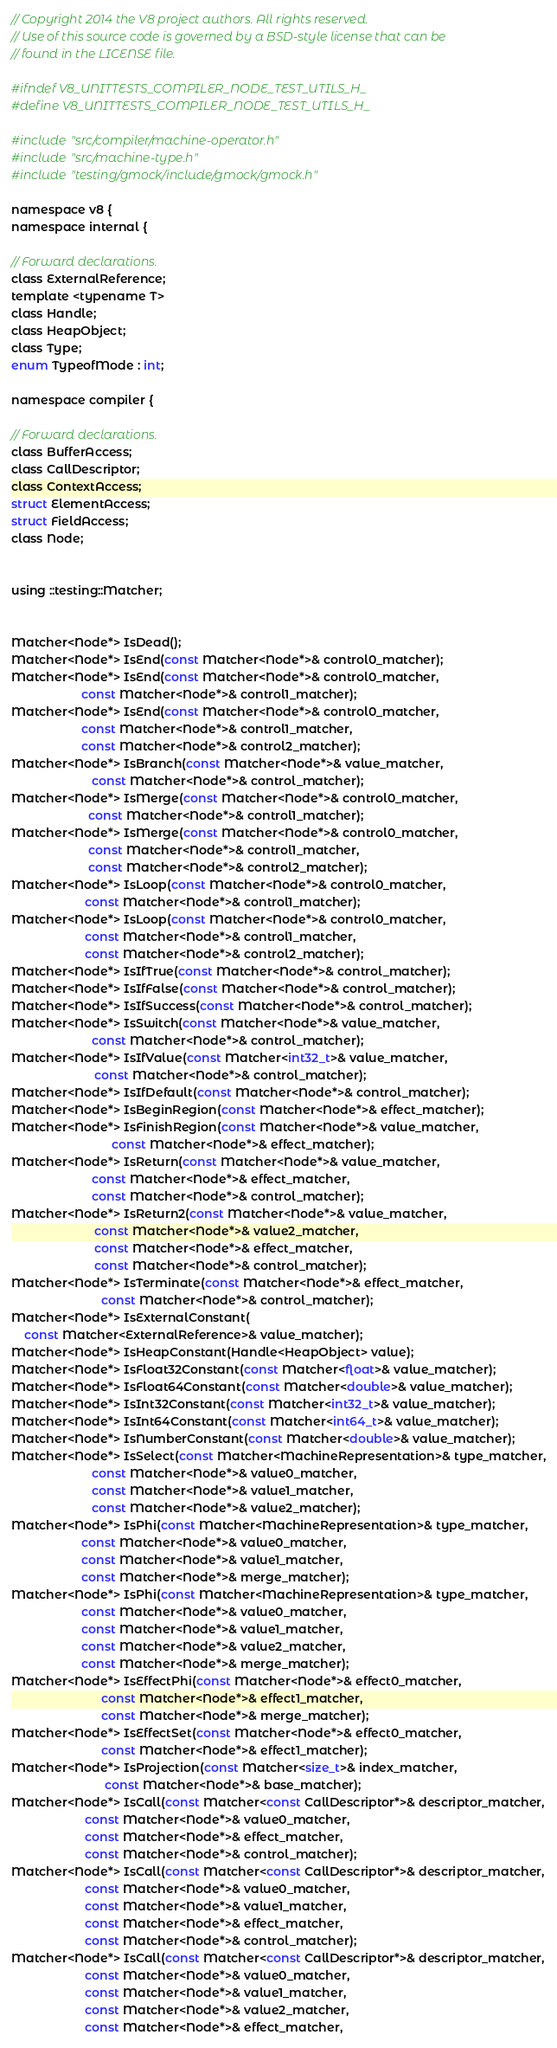<code> <loc_0><loc_0><loc_500><loc_500><_C_>// Copyright 2014 the V8 project authors. All rights reserved.
// Use of this source code is governed by a BSD-style license that can be
// found in the LICENSE file.

#ifndef V8_UNITTESTS_COMPILER_NODE_TEST_UTILS_H_
#define V8_UNITTESTS_COMPILER_NODE_TEST_UTILS_H_

#include "src/compiler/machine-operator.h"
#include "src/machine-type.h"
#include "testing/gmock/include/gmock/gmock.h"

namespace v8 {
namespace internal {

// Forward declarations.
class ExternalReference;
template <typename T>
class Handle;
class HeapObject;
class Type;
enum TypeofMode : int;

namespace compiler {

// Forward declarations.
class BufferAccess;
class CallDescriptor;
class ContextAccess;
struct ElementAccess;
struct FieldAccess;
class Node;


using ::testing::Matcher;


Matcher<Node*> IsDead();
Matcher<Node*> IsEnd(const Matcher<Node*>& control0_matcher);
Matcher<Node*> IsEnd(const Matcher<Node*>& control0_matcher,
                     const Matcher<Node*>& control1_matcher);
Matcher<Node*> IsEnd(const Matcher<Node*>& control0_matcher,
                     const Matcher<Node*>& control1_matcher,
                     const Matcher<Node*>& control2_matcher);
Matcher<Node*> IsBranch(const Matcher<Node*>& value_matcher,
                        const Matcher<Node*>& control_matcher);
Matcher<Node*> IsMerge(const Matcher<Node*>& control0_matcher,
                       const Matcher<Node*>& control1_matcher);
Matcher<Node*> IsMerge(const Matcher<Node*>& control0_matcher,
                       const Matcher<Node*>& control1_matcher,
                       const Matcher<Node*>& control2_matcher);
Matcher<Node*> IsLoop(const Matcher<Node*>& control0_matcher,
                      const Matcher<Node*>& control1_matcher);
Matcher<Node*> IsLoop(const Matcher<Node*>& control0_matcher,
                      const Matcher<Node*>& control1_matcher,
                      const Matcher<Node*>& control2_matcher);
Matcher<Node*> IsIfTrue(const Matcher<Node*>& control_matcher);
Matcher<Node*> IsIfFalse(const Matcher<Node*>& control_matcher);
Matcher<Node*> IsIfSuccess(const Matcher<Node*>& control_matcher);
Matcher<Node*> IsSwitch(const Matcher<Node*>& value_matcher,
                        const Matcher<Node*>& control_matcher);
Matcher<Node*> IsIfValue(const Matcher<int32_t>& value_matcher,
                         const Matcher<Node*>& control_matcher);
Matcher<Node*> IsIfDefault(const Matcher<Node*>& control_matcher);
Matcher<Node*> IsBeginRegion(const Matcher<Node*>& effect_matcher);
Matcher<Node*> IsFinishRegion(const Matcher<Node*>& value_matcher,
                              const Matcher<Node*>& effect_matcher);
Matcher<Node*> IsReturn(const Matcher<Node*>& value_matcher,
                        const Matcher<Node*>& effect_matcher,
                        const Matcher<Node*>& control_matcher);
Matcher<Node*> IsReturn2(const Matcher<Node*>& value_matcher,
                         const Matcher<Node*>& value2_matcher,
                         const Matcher<Node*>& effect_matcher,
                         const Matcher<Node*>& control_matcher);
Matcher<Node*> IsTerminate(const Matcher<Node*>& effect_matcher,
                           const Matcher<Node*>& control_matcher);
Matcher<Node*> IsExternalConstant(
    const Matcher<ExternalReference>& value_matcher);
Matcher<Node*> IsHeapConstant(Handle<HeapObject> value);
Matcher<Node*> IsFloat32Constant(const Matcher<float>& value_matcher);
Matcher<Node*> IsFloat64Constant(const Matcher<double>& value_matcher);
Matcher<Node*> IsInt32Constant(const Matcher<int32_t>& value_matcher);
Matcher<Node*> IsInt64Constant(const Matcher<int64_t>& value_matcher);
Matcher<Node*> IsNumberConstant(const Matcher<double>& value_matcher);
Matcher<Node*> IsSelect(const Matcher<MachineRepresentation>& type_matcher,
                        const Matcher<Node*>& value0_matcher,
                        const Matcher<Node*>& value1_matcher,
                        const Matcher<Node*>& value2_matcher);
Matcher<Node*> IsPhi(const Matcher<MachineRepresentation>& type_matcher,
                     const Matcher<Node*>& value0_matcher,
                     const Matcher<Node*>& value1_matcher,
                     const Matcher<Node*>& merge_matcher);
Matcher<Node*> IsPhi(const Matcher<MachineRepresentation>& type_matcher,
                     const Matcher<Node*>& value0_matcher,
                     const Matcher<Node*>& value1_matcher,
                     const Matcher<Node*>& value2_matcher,
                     const Matcher<Node*>& merge_matcher);
Matcher<Node*> IsEffectPhi(const Matcher<Node*>& effect0_matcher,
                           const Matcher<Node*>& effect1_matcher,
                           const Matcher<Node*>& merge_matcher);
Matcher<Node*> IsEffectSet(const Matcher<Node*>& effect0_matcher,
                           const Matcher<Node*>& effect1_matcher);
Matcher<Node*> IsProjection(const Matcher<size_t>& index_matcher,
                            const Matcher<Node*>& base_matcher);
Matcher<Node*> IsCall(const Matcher<const CallDescriptor*>& descriptor_matcher,
                      const Matcher<Node*>& value0_matcher,
                      const Matcher<Node*>& effect_matcher,
                      const Matcher<Node*>& control_matcher);
Matcher<Node*> IsCall(const Matcher<const CallDescriptor*>& descriptor_matcher,
                      const Matcher<Node*>& value0_matcher,
                      const Matcher<Node*>& value1_matcher,
                      const Matcher<Node*>& effect_matcher,
                      const Matcher<Node*>& control_matcher);
Matcher<Node*> IsCall(const Matcher<const CallDescriptor*>& descriptor_matcher,
                      const Matcher<Node*>& value0_matcher,
                      const Matcher<Node*>& value1_matcher,
                      const Matcher<Node*>& value2_matcher,
                      const Matcher<Node*>& effect_matcher,</code> 